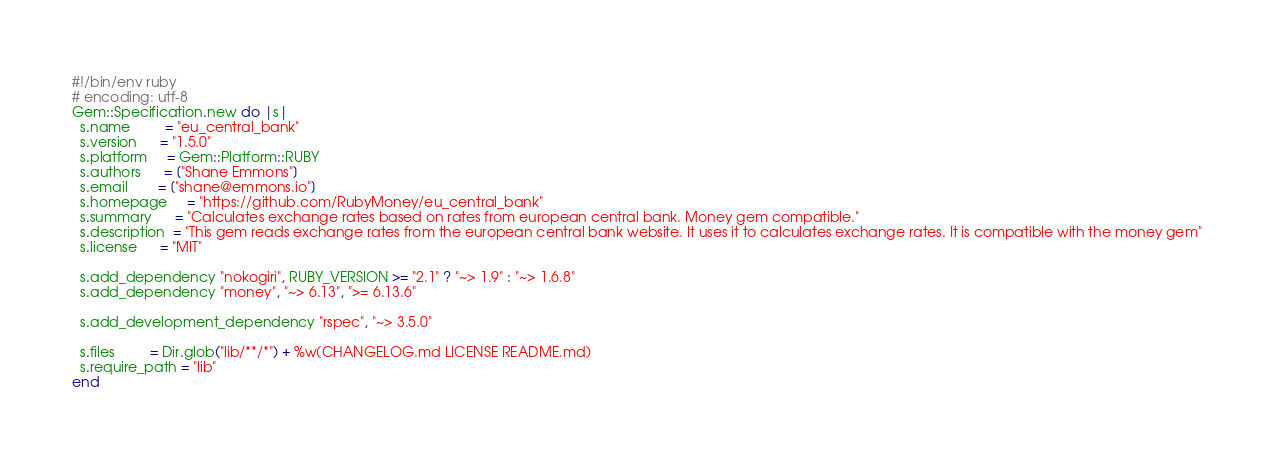<code> <loc_0><loc_0><loc_500><loc_500><_Ruby_>#!/bin/env ruby
# encoding: utf-8
Gem::Specification.new do |s|
  s.name         = "eu_central_bank"
  s.version      = "1.5.0"
  s.platform     = Gem::Platform::RUBY
  s.authors      = ["Shane Emmons"]
  s.email        = ["shane@emmons.io"]
  s.homepage     = "https://github.com/RubyMoney/eu_central_bank"
  s.summary      = "Calculates exchange rates based on rates from european central bank. Money gem compatible."
  s.description  = "This gem reads exchange rates from the european central bank website. It uses it to calculates exchange rates. It is compatible with the money gem"
  s.license      = "MIT"

  s.add_dependency "nokogiri", RUBY_VERSION >= "2.1" ? "~> 1.9" : "~> 1.6.8"
  s.add_dependency "money", "~> 6.13", ">= 6.13.6"

  s.add_development_dependency "rspec", "~> 3.5.0"

  s.files         = Dir.glob("lib/**/*") + %w(CHANGELOG.md LICENSE README.md)
  s.require_path = "lib"
end
</code> 